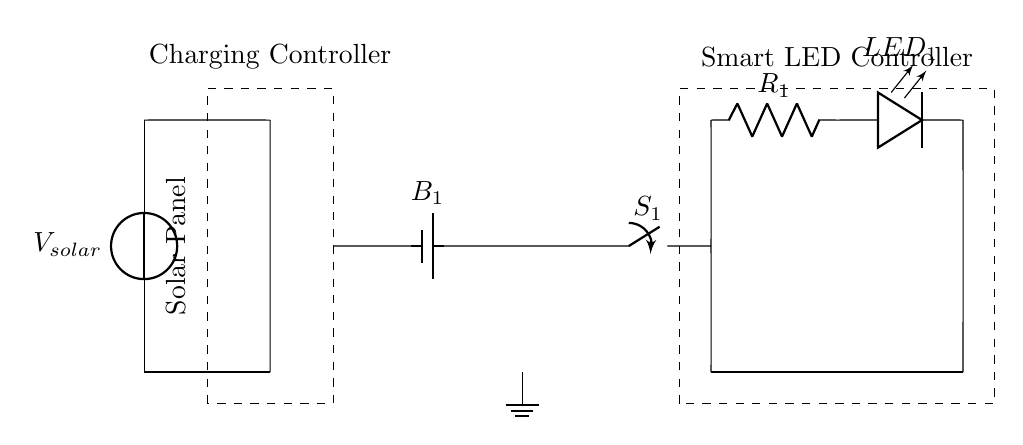What is the source of energy in this circuit? The circuit includes a solar panel that acts as the voltage source. This is indicated at the top of the circuit diagram labeled as V solar.
Answer: solar panel What type of battery is used in the circuit? The circuit shows a battery labeled as B1. In most contexts, B implies a rechargeable battery suitable for storing energy from the solar panel.
Answer: B1 How many resistors are present in the circuit? The circuit contains one resistor labeled R1 as part of the LED circuit, which is shown connected to the LED.
Answer: one What is the role of the charging controller? The charging controller manages the flow from the solar panel to the battery, ensuring efficient charging and preventing overcharging. This function is indicated by its placement in the circuit after the solar panel.
Answer: manage charging Which component controls the LED usage? The smart LED controller allows for intelligent management of the LED's power, adapting to various conditions; its label shows it's separate from the LED components but directly affects their behavior.
Answer: smart LED controller What happens when the switch S1 is closed? Closing switch S1 completes the circuit, allowing current to flow from the battery to the LED via R1; thus, the LED will light up. This scenario can be visualized by following the connections after S1.
Answer: LED lights up What is the purpose of the ground connection? The ground connection serves as a reference point for the voltage levels in the circuit, ensuring safety and stable operation, as shown at the bottom left of the circuit diagram.
Answer: reference point 